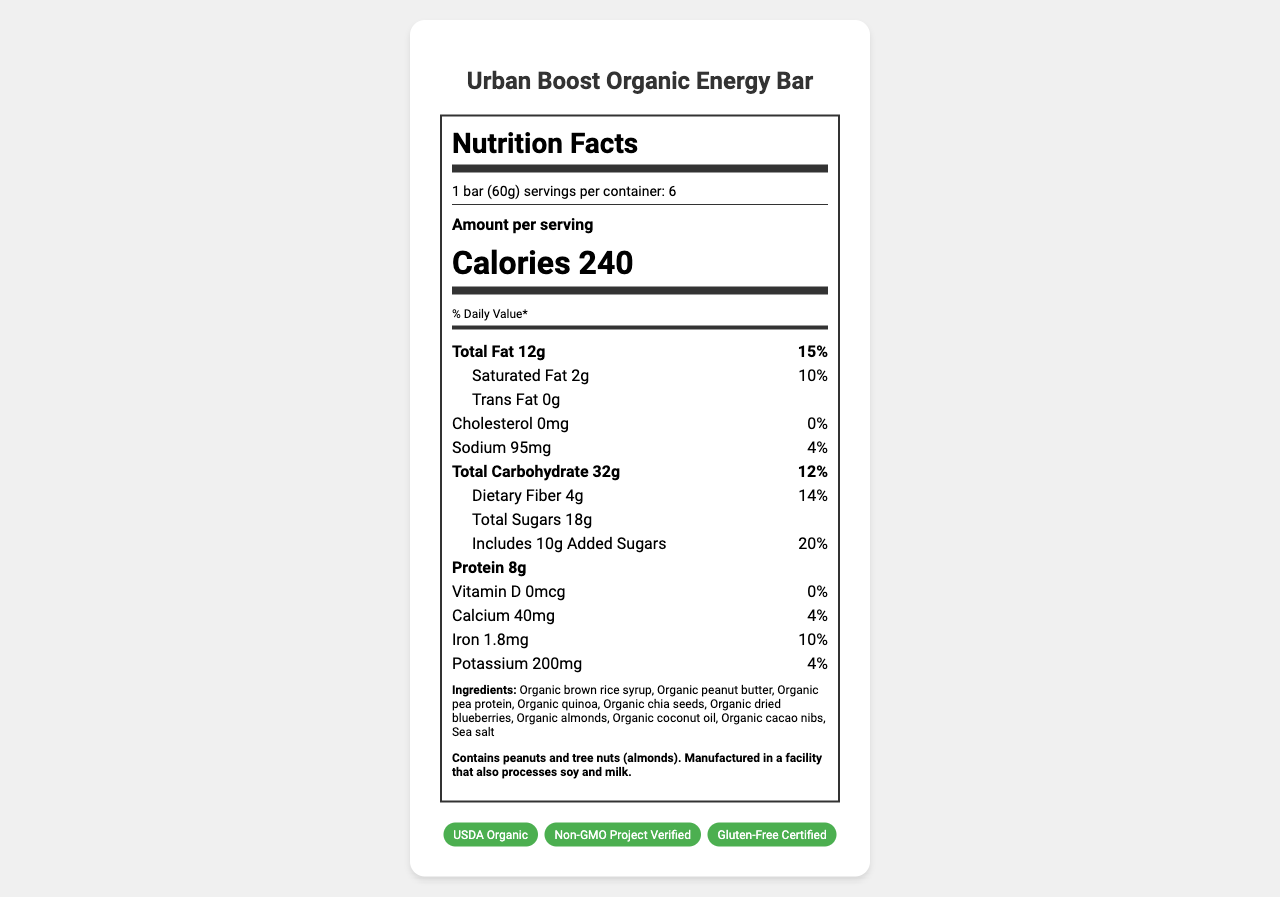what is the serving size? The serving size is clearly mentioned as "1 bar (60g)" in the document.
Answer: 1 bar (60g) how many calories are in one serving? The calories section shows that one serving contains 240 calories.
Answer: 240 what percentage of the daily value for total fat does one bar provide? The total fat section indicates that one bar provides 12g of fat, which is 15% of the daily value.
Answer: 15% how much dietary fiber is in each serving? In the total carbohydrate section, it mentions dietary fiber is 4g.
Answer: 4g what are the main ingredients of the energy bar? The ingredients list includes various items such as organic brown rice syrup, organic peanut butter, organic pea protein, organic quinoa, and others.
Answer: Organic brown rice syrup, Organic peanut butter, Organic pea protein, Organic quinoa... are there any allergen warnings? The allergen information states it contains peanuts and tree nuts (almonds) and is manufactured in a facility that also processes soy and milk.
Answer: Yes which certifications does the product have? A. Gluten-Free Certified B. Kosher Certified C. Non-GMO Project Verified D. USDA Organic E. Halal Certified The certifications listed are USDA Organic, Non-GMO Project Verified, and Gluten-Free Certified.
Answer: A, C, D what is the daily value percentage for iron in one serving? A. 4% B. 10% C. 15% D. 20% The nutrient information shows that one serving contains 10% of the daily value for iron.
Answer: B does the product contain any trans fat? The trans fat section shows "0g," indicating there is no trans fat in the product.
Answer: No is the product's sodium content high? The sodium content is 95mg, which is 4% of the daily value, suggesting it is relatively low in sodium.
Answer: No summarize the key points of the nutrition label The Urban Boost Organic Energy Bar has a serving size of 1 bar (60g) with 240 calories. It includes 12g of total fat (15% daily value), 2g of saturated fat (10% daily value), 0g of trans fat, 95mg of sodium (4% daily value), 32g of total carbohydrates (12% daily value), 4g of dietary fiber (14% daily value), 18g of total sugars (includes 10g added sugars), and 8g of protein. Essential nutrients include 0% vitamin D, 4% calcium, 10% iron, and 4% potassium. The product contains organic ingredients and certifications such as USDA Organic, Non-GMO Project Verified, and Gluten-Free Certified.
Answer: Urban Boost Organic Energy Bar, 240 calories per bar, 12g total fat, 32g total carbohydrates, 4g dietary fiber, 18g total sugars (includes 10g added sugars), 8g protein, and contains several organic ingredients. what is the product's shelf life after opening? The storage instructions indicate to consume the product within 14 days of opening for maximum freshness.
Answer: 14 days does the product contain animal-derived ingredients? While the ingredients list seems to be plant-based, the document does not provide explicit information that confirms the absence of all animal-derived ingredients.
Answer: Not enough information 